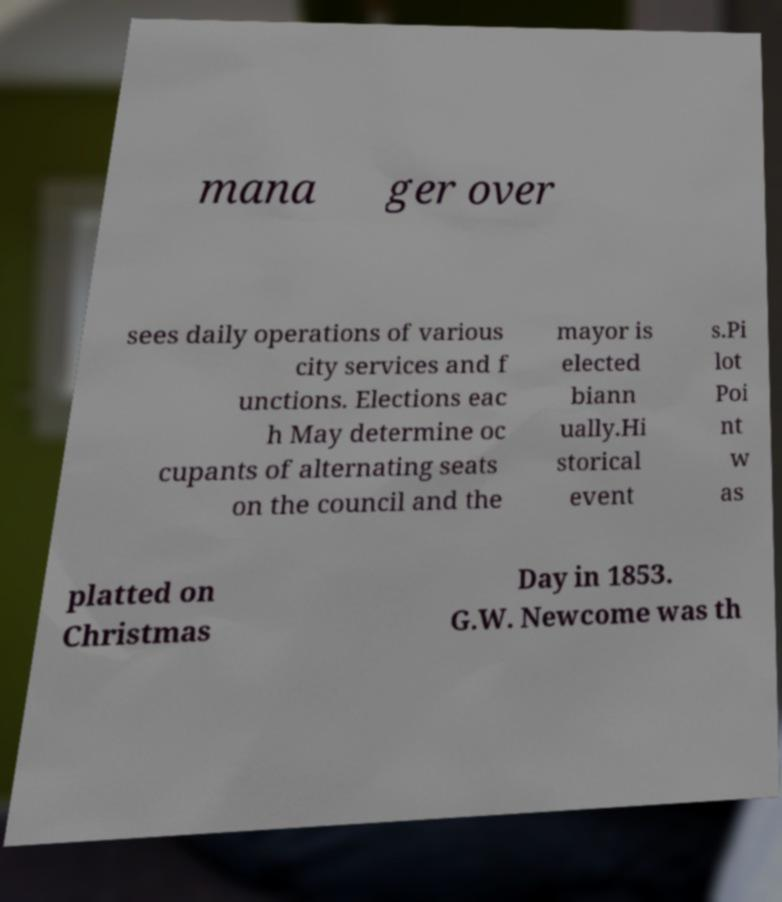Please identify and transcribe the text found in this image. mana ger over sees daily operations of various city services and f unctions. Elections eac h May determine oc cupants of alternating seats on the council and the mayor is elected biann ually.Hi storical event s.Pi lot Poi nt w as platted on Christmas Day in 1853. G.W. Newcome was th 